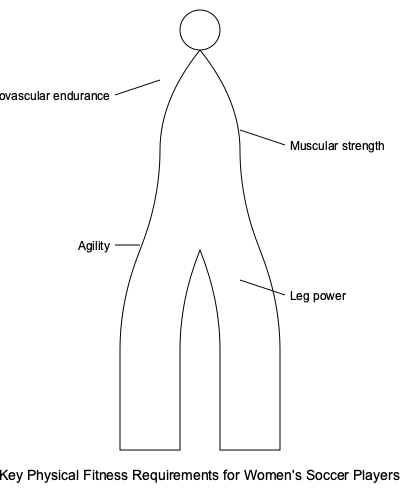Which of the following physical fitness components is crucial for a women's soccer player like Jennifer Martin to maintain quick directional changes and rapid movements on the field? To answer this question, let's consider the key physical fitness requirements for women's soccer players as shown in the diagram:

1. Cardiovascular endurance: This is important for maintaining stamina throughout the game, but it doesn't specifically relate to quick movements.

2. Muscular strength: While essential for overall performance, it's not the primary component for rapid directional changes.

3. Agility: This is the ability to change direction quickly and maintain balance. It's crucial for soccer players to make sudden turns, dodge opponents, and react to the ball's movement.

4. Leg power: This contributes to sprinting and jumping ability, but it's not the primary factor in quick directional changes.

Among these components, agility is the most directly related to maintaining quick directional changes and rapid movements on the field. Soccer players like Jennifer Martin need to be highly agile to effectively maneuver around opponents, change direction quickly when chasing or controlling the ball, and react swiftly to game situations.
Answer: Agility 